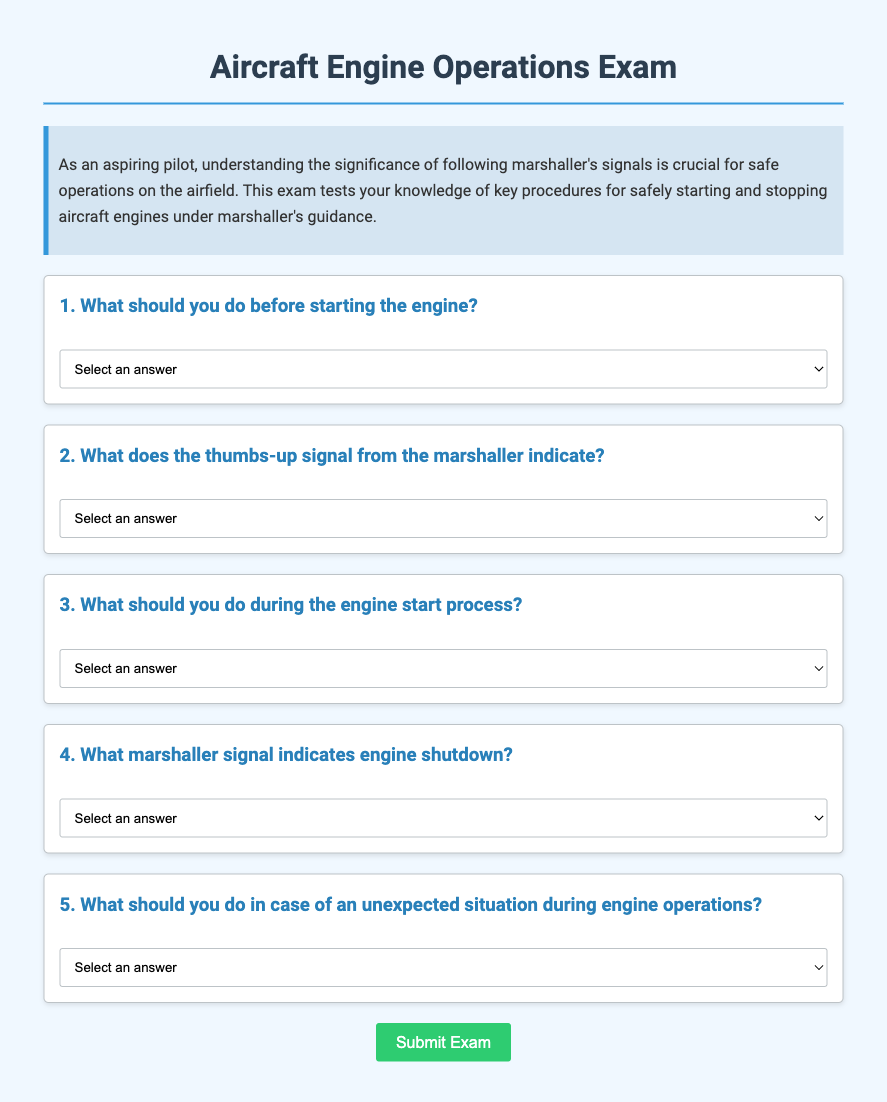What is the title of the document? The title of the document is displayed in the header section and is "Aircraft Engine Operations Exam."
Answer: Aircraft Engine Operations Exam What is the purpose of the exam? The purpose of the exam is explained in the introductory paragraph, which mentions understanding the significance of following marshaller's signals.
Answer: To understand the significance of following marshaller's signals What does the thumbs-up signal indicate? The thumbs-up signal is one of the questions listed in the exam, specifically asking what it indicates, which is readiness for engine start.
Answer: Readiness for engine start How many questions are in the exam? The document contains five questions related to safely starting and stopping aircraft engines under marshaller's guidance.
Answer: Five What should you do before starting the engine? This is one of the exam questions, and it specifically asks what actions to take before starting the engine, which should include ensuring clear communication with the marshaller.
Answer: Ensure clear communication with the marshaller What action should you take in case of an unexpected situation? The exam question focuses on the expected action during an unexpected situation, which is to immediately follow the marshaller's emergency hand signals.
Answer: Immediately follow the marshaller's emergency hand signals What is the color of the body background in the document? The background color of the body is specified in the CSS, which is a light shade of blue (#f0f8ff).
Answer: Light blue What does the document emphasize regarding engine start processes? The document emphasizes the importance of maintaining visual contact with the marshaller during the engine start process, as stated in one of the questions.
Answer: Maintain visual contact with the marshaller What is the color of the button when hovered over? The button's hover color is specified in the CSS, which changes to a darker green when hovered over.
Answer: Darker green 